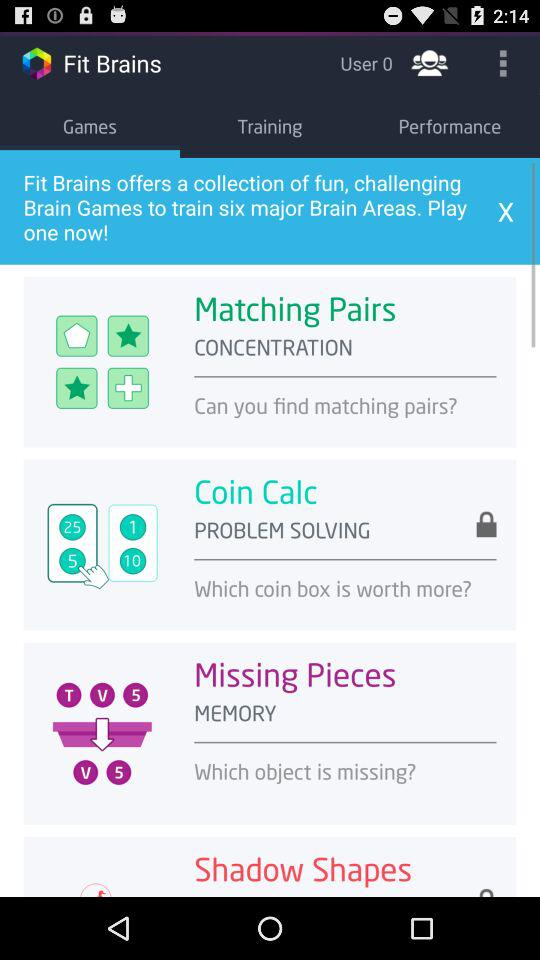How many followers are there?
When the provided information is insufficient, respond with <no answer>. <no answer> 